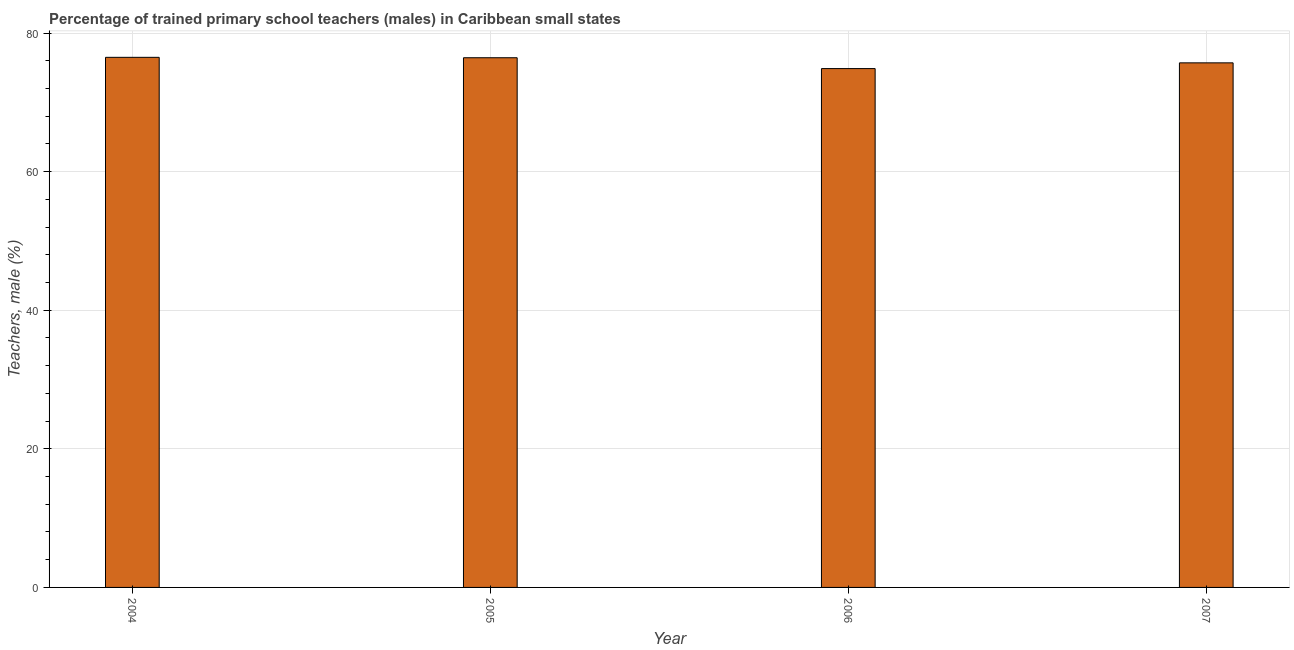Does the graph contain grids?
Your answer should be compact. Yes. What is the title of the graph?
Your response must be concise. Percentage of trained primary school teachers (males) in Caribbean small states. What is the label or title of the X-axis?
Your answer should be very brief. Year. What is the label or title of the Y-axis?
Your answer should be very brief. Teachers, male (%). What is the percentage of trained male teachers in 2007?
Give a very brief answer. 75.7. Across all years, what is the maximum percentage of trained male teachers?
Your answer should be very brief. 76.5. Across all years, what is the minimum percentage of trained male teachers?
Offer a very short reply. 74.88. In which year was the percentage of trained male teachers maximum?
Give a very brief answer. 2004. What is the sum of the percentage of trained male teachers?
Your response must be concise. 303.53. What is the difference between the percentage of trained male teachers in 2004 and 2006?
Make the answer very short. 1.62. What is the average percentage of trained male teachers per year?
Your answer should be very brief. 75.88. What is the median percentage of trained male teachers?
Keep it short and to the point. 76.07. In how many years, is the percentage of trained male teachers greater than 60 %?
Your answer should be compact. 4. Is the difference between the percentage of trained male teachers in 2006 and 2007 greater than the difference between any two years?
Keep it short and to the point. No. What is the difference between the highest and the second highest percentage of trained male teachers?
Ensure brevity in your answer.  0.06. Is the sum of the percentage of trained male teachers in 2004 and 2006 greater than the maximum percentage of trained male teachers across all years?
Your response must be concise. Yes. What is the difference between the highest and the lowest percentage of trained male teachers?
Your response must be concise. 1.62. How many bars are there?
Offer a very short reply. 4. Are the values on the major ticks of Y-axis written in scientific E-notation?
Ensure brevity in your answer.  No. What is the Teachers, male (%) of 2004?
Give a very brief answer. 76.5. What is the Teachers, male (%) of 2005?
Your answer should be very brief. 76.44. What is the Teachers, male (%) in 2006?
Your answer should be compact. 74.88. What is the Teachers, male (%) of 2007?
Provide a short and direct response. 75.7. What is the difference between the Teachers, male (%) in 2004 and 2005?
Ensure brevity in your answer.  0.06. What is the difference between the Teachers, male (%) in 2004 and 2006?
Ensure brevity in your answer.  1.62. What is the difference between the Teachers, male (%) in 2004 and 2007?
Your answer should be compact. 0.8. What is the difference between the Teachers, male (%) in 2005 and 2006?
Your answer should be very brief. 1.56. What is the difference between the Teachers, male (%) in 2005 and 2007?
Provide a short and direct response. 0.74. What is the difference between the Teachers, male (%) in 2006 and 2007?
Provide a short and direct response. -0.83. What is the ratio of the Teachers, male (%) in 2004 to that in 2005?
Ensure brevity in your answer.  1. What is the ratio of the Teachers, male (%) in 2004 to that in 2007?
Make the answer very short. 1.01. What is the ratio of the Teachers, male (%) in 2006 to that in 2007?
Keep it short and to the point. 0.99. 